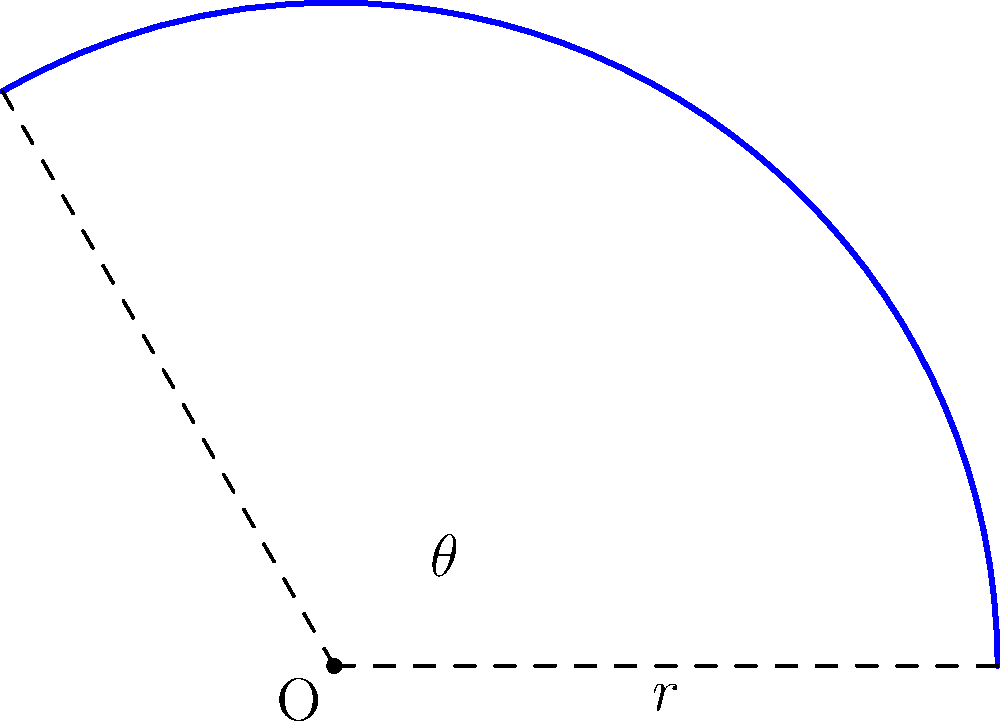After your intense workout, you notice a curved running track at your gym. The track forms an arc with a central angle of $120^\circ$ and a radius of 30 meters. What is the length of this curved track to the nearest meter? (Use $\pi \approx 3.14$) To find the arc length of the curved running track, we'll use the formula:

$$s = r\theta$$

Where:
$s$ = arc length
$r$ = radius
$\theta$ = central angle in radians

Steps:
1) We have $r = 30$ meters and the angle is $120^\circ$.

2) Convert the angle from degrees to radians:
   $$\theta = 120^\circ \times \frac{\pi}{180^\circ} = \frac{2\pi}{3} \approx 2.09$$

3) Now apply the formula:
   $$s = r\theta = 30 \times \frac{2\pi}{3} = 20\pi$$

4) Calculate the result:
   $$s = 20 \times 3.14 = 62.8$$

5) Rounding to the nearest meter:
   $$s \approx 63 \text{ meters}$$
Answer: 63 meters 